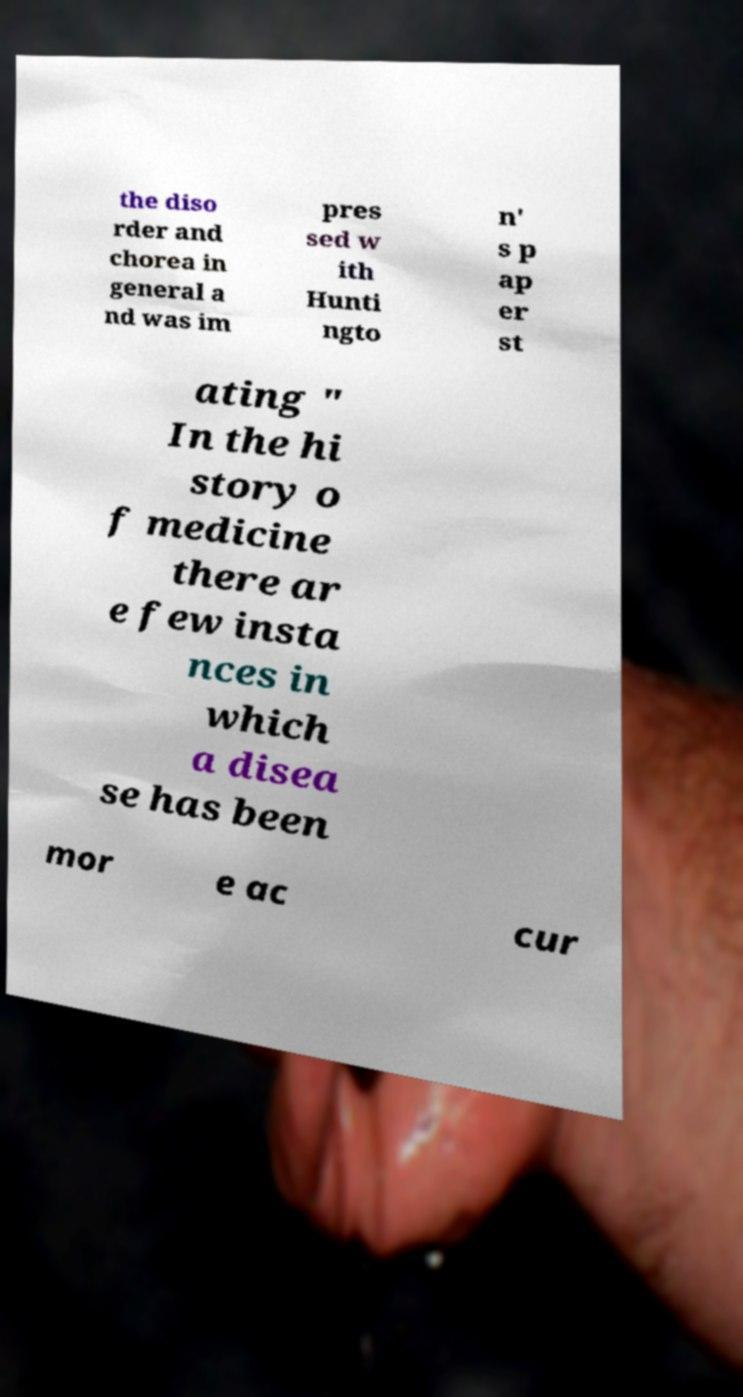For documentation purposes, I need the text within this image transcribed. Could you provide that? the diso rder and chorea in general a nd was im pres sed w ith Hunti ngto n' s p ap er st ating " In the hi story o f medicine there ar e few insta nces in which a disea se has been mor e ac cur 